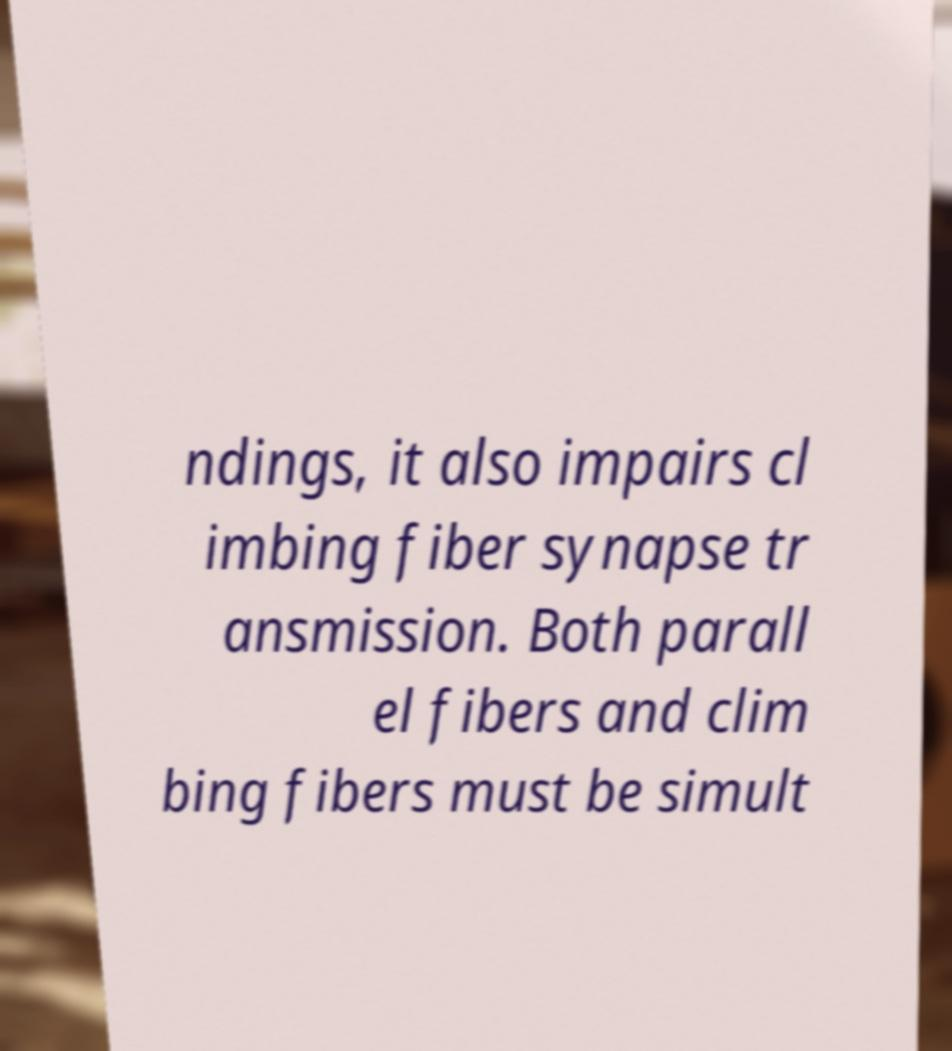Please identify and transcribe the text found in this image. ndings, it also impairs cl imbing fiber synapse tr ansmission. Both parall el fibers and clim bing fibers must be simult 